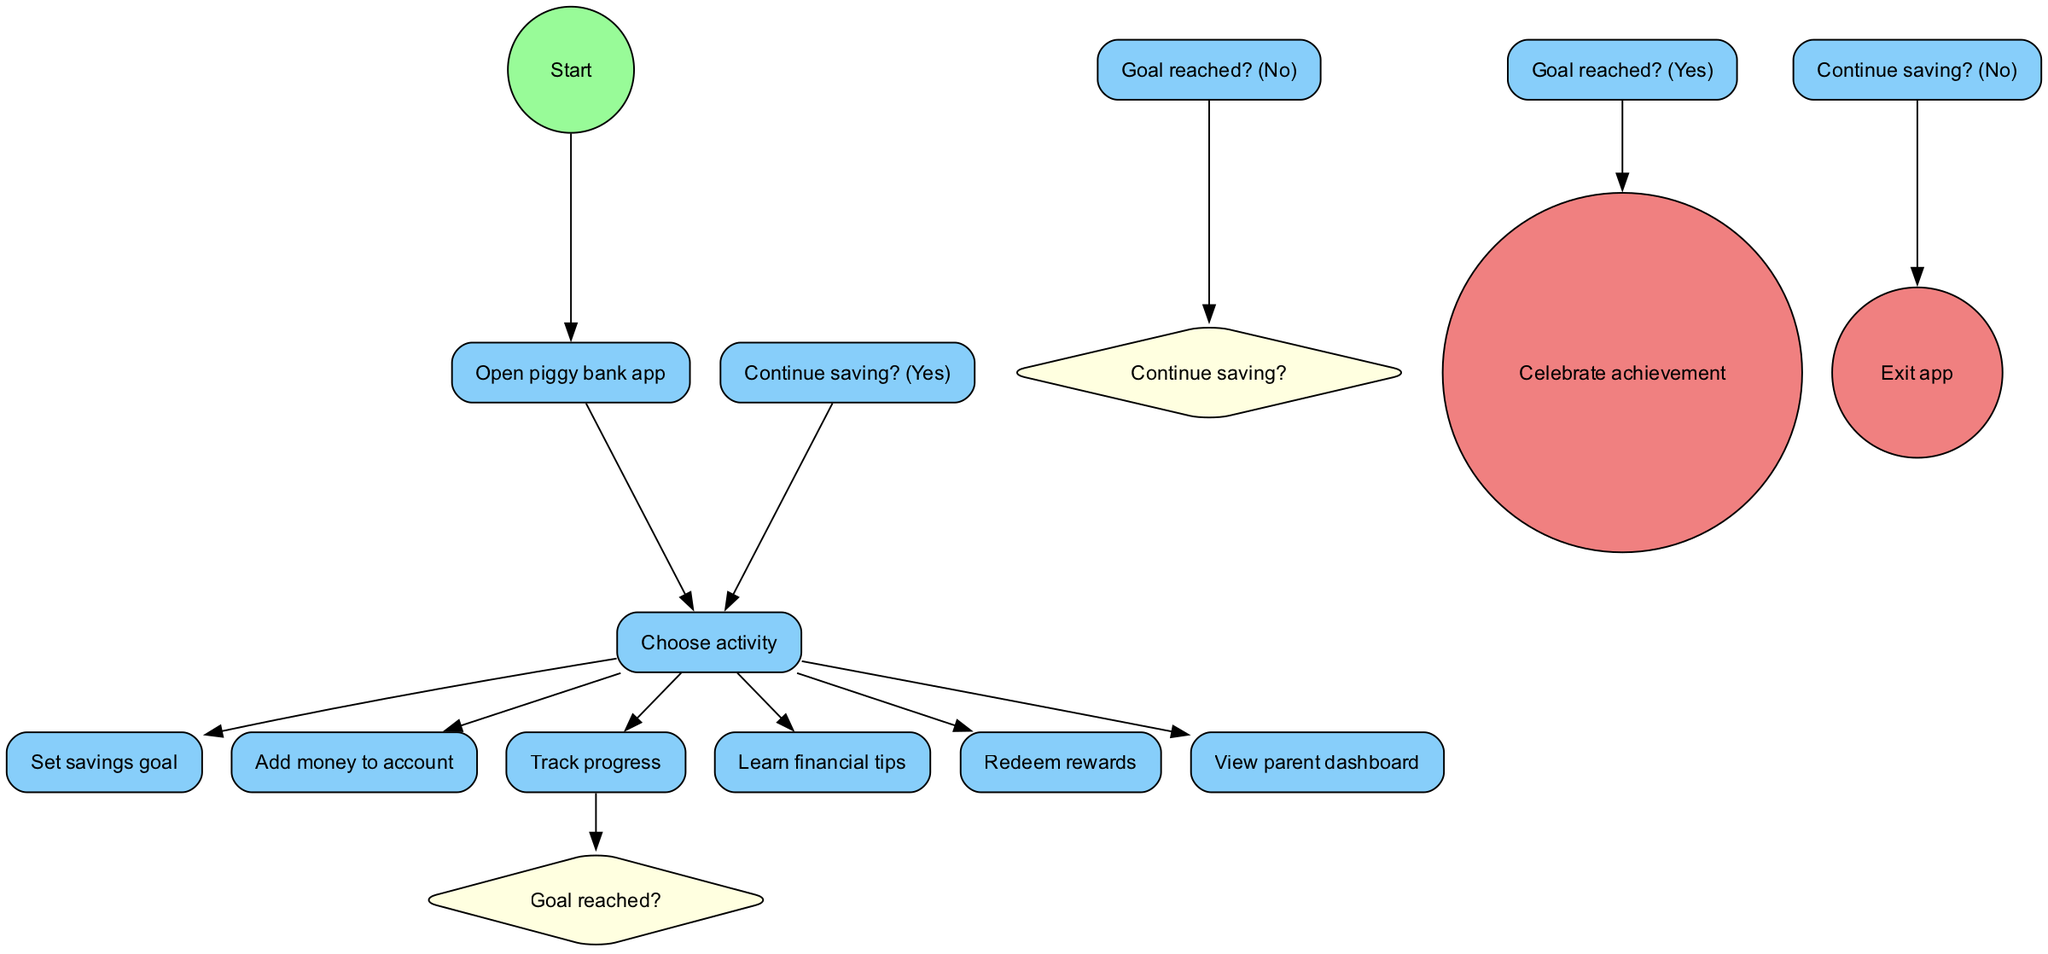What is the starting action in the diagram? The starting action is "Open piggy bank app," which is the first node that the flow begins from in the diagram.
Answer: Open piggy bank app How many activities are listed in the diagram? There are seven activities in the diagram. Each activity represents a step or feature of the digital piggy bank app for kids.
Answer: 7 What happens after "Track progress"? After "Track progress," the decision node "Goal reached?" is encountered, which determines the next steps based on whether the savings goal has been reached.
Answer: Goal reached? What is the next step if the goal is reached? If the goal is reached, the next step is to "Celebrate achievement," which indicates that the user has successfully achieved their savings goal.
Answer: Celebrate achievement What can a user choose to do after setting a savings goal? After setting a savings goal, the user can choose several activities, including "Add money to account," "Track progress," "Learn financial tips," "Redeem rewards," or "View parent dashboard."
Answer: Add money to account, Track progress, Learn financial tips, Redeem rewards, View parent dashboard If a user decides not to continue saving, what is the final action? If a user decides not to continue saving, the final action in the flow is "Exit app," which indicates that the user has chosen to leave the application.
Answer: Exit app What type of node is "Goal reached?" "Goal reached?" is a decision node, represented in the diagram as a diamond shape, indicating a point where a choice must be made based on the user's progress.
Answer: Decision node What must a user do to see the parent dashboard? To see the parent dashboard, a user must choose the "View parent dashboard" activity from the main activity selection options provided in the app.
Answer: View parent dashboard What two paths can result after "Goal reached?" After "Goal reached?", there are two possible paths: if the answer is "Yes," the user proceeds to "Celebrate achievement," and if "No," they are directed to "Continue saving?"
Answer: Celebrate achievement, Continue saving? 